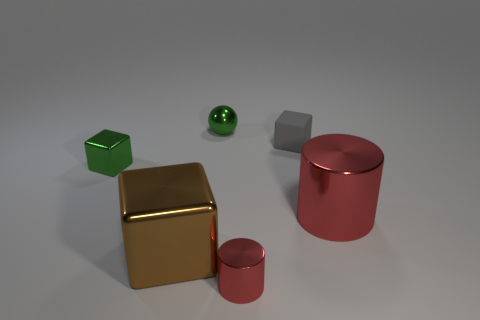Are there more red cylinders that are in front of the large red metallic thing than tiny blue metal cylinders?
Your answer should be compact. Yes. What is the size of the other cylinder that is the same material as the small cylinder?
Ensure brevity in your answer.  Large. Are there any big metal cylinders of the same color as the matte block?
Offer a very short reply. No. How many objects are big brown cylinders or blocks that are behind the brown metal object?
Your response must be concise. 2. Is the number of brown cubes greater than the number of red shiny objects?
Make the answer very short. No. What is the size of the thing that is the same color as the ball?
Offer a terse response. Small. Is there a cube that has the same material as the large cylinder?
Ensure brevity in your answer.  Yes. The small metal thing that is both behind the tiny cylinder and in front of the metallic ball has what shape?
Make the answer very short. Cube. How many other things are the same shape as the brown thing?
Provide a short and direct response. 2. The brown metallic block is what size?
Make the answer very short. Large. 